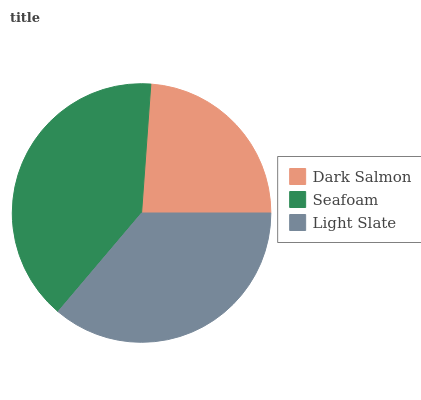Is Dark Salmon the minimum?
Answer yes or no. Yes. Is Seafoam the maximum?
Answer yes or no. Yes. Is Light Slate the minimum?
Answer yes or no. No. Is Light Slate the maximum?
Answer yes or no. No. Is Seafoam greater than Light Slate?
Answer yes or no. Yes. Is Light Slate less than Seafoam?
Answer yes or no. Yes. Is Light Slate greater than Seafoam?
Answer yes or no. No. Is Seafoam less than Light Slate?
Answer yes or no. No. Is Light Slate the high median?
Answer yes or no. Yes. Is Light Slate the low median?
Answer yes or no. Yes. Is Dark Salmon the high median?
Answer yes or no. No. Is Dark Salmon the low median?
Answer yes or no. No. 